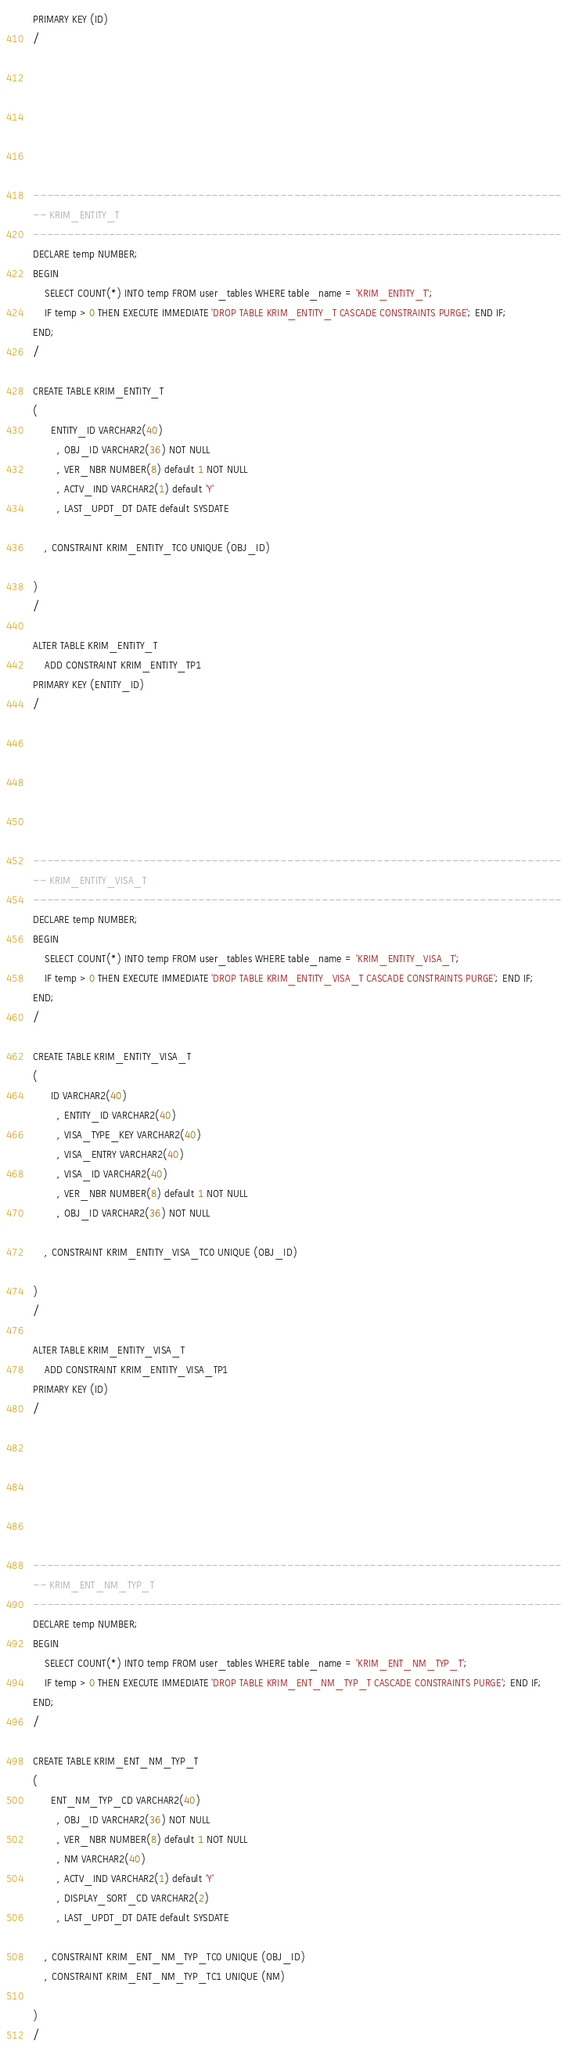<code> <loc_0><loc_0><loc_500><loc_500><_SQL_>PRIMARY KEY (ID)
/







-----------------------------------------------------------------------------
-- KRIM_ENTITY_T
-----------------------------------------------------------------------------
DECLARE temp NUMBER;
BEGIN
    SELECT COUNT(*) INTO temp FROM user_tables WHERE table_name = 'KRIM_ENTITY_T';
    IF temp > 0 THEN EXECUTE IMMEDIATE 'DROP TABLE KRIM_ENTITY_T CASCADE CONSTRAINTS PURGE'; END IF;
END;
/

CREATE TABLE KRIM_ENTITY_T
(
      ENTITY_ID VARCHAR2(40)
        , OBJ_ID VARCHAR2(36) NOT NULL
        , VER_NBR NUMBER(8) default 1 NOT NULL
        , ACTV_IND VARCHAR2(1) default 'Y'
        , LAST_UPDT_DT DATE default SYSDATE
    
    , CONSTRAINT KRIM_ENTITY_TC0 UNIQUE (OBJ_ID)

)
/

ALTER TABLE KRIM_ENTITY_T
    ADD CONSTRAINT KRIM_ENTITY_TP1
PRIMARY KEY (ENTITY_ID)
/







-----------------------------------------------------------------------------
-- KRIM_ENTITY_VISA_T
-----------------------------------------------------------------------------
DECLARE temp NUMBER;
BEGIN
    SELECT COUNT(*) INTO temp FROM user_tables WHERE table_name = 'KRIM_ENTITY_VISA_T';
    IF temp > 0 THEN EXECUTE IMMEDIATE 'DROP TABLE KRIM_ENTITY_VISA_T CASCADE CONSTRAINTS PURGE'; END IF;
END;
/

CREATE TABLE KRIM_ENTITY_VISA_T
(
      ID VARCHAR2(40)
        , ENTITY_ID VARCHAR2(40)
        , VISA_TYPE_KEY VARCHAR2(40)
        , VISA_ENTRY VARCHAR2(40)
        , VISA_ID VARCHAR2(40)
        , VER_NBR NUMBER(8) default 1 NOT NULL
        , OBJ_ID VARCHAR2(36) NOT NULL
    
    , CONSTRAINT KRIM_ENTITY_VISA_TC0 UNIQUE (OBJ_ID)

)
/

ALTER TABLE KRIM_ENTITY_VISA_T
    ADD CONSTRAINT KRIM_ENTITY_VISA_TP1
PRIMARY KEY (ID)
/







-----------------------------------------------------------------------------
-- KRIM_ENT_NM_TYP_T
-----------------------------------------------------------------------------
DECLARE temp NUMBER;
BEGIN
    SELECT COUNT(*) INTO temp FROM user_tables WHERE table_name = 'KRIM_ENT_NM_TYP_T';
    IF temp > 0 THEN EXECUTE IMMEDIATE 'DROP TABLE KRIM_ENT_NM_TYP_T CASCADE CONSTRAINTS PURGE'; END IF;
END;
/

CREATE TABLE KRIM_ENT_NM_TYP_T
(
      ENT_NM_TYP_CD VARCHAR2(40)
        , OBJ_ID VARCHAR2(36) NOT NULL
        , VER_NBR NUMBER(8) default 1 NOT NULL
        , NM VARCHAR2(40)
        , ACTV_IND VARCHAR2(1) default 'Y'
        , DISPLAY_SORT_CD VARCHAR2(2)
        , LAST_UPDT_DT DATE default SYSDATE
    
    , CONSTRAINT KRIM_ENT_NM_TYP_TC0 UNIQUE (OBJ_ID)
    , CONSTRAINT KRIM_ENT_NM_TYP_TC1 UNIQUE (NM)

)
/
</code> 